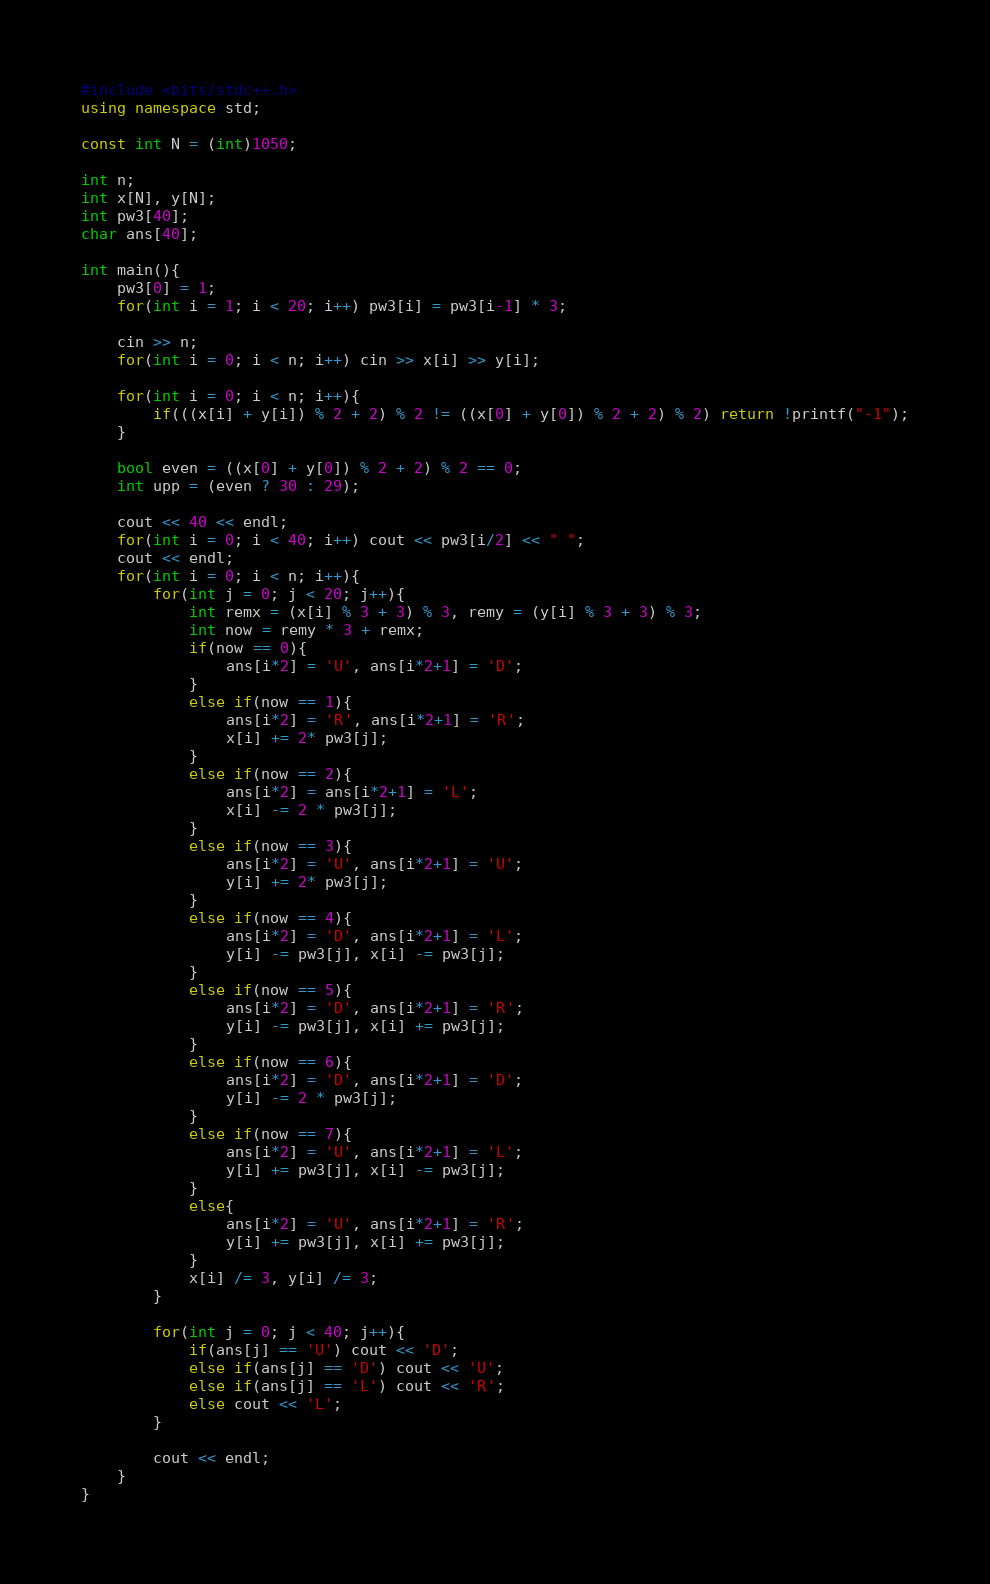<code> <loc_0><loc_0><loc_500><loc_500><_C++_>#include <bits/stdc++.h>
using namespace std;

const int N = (int)1050;

int n;
int x[N], y[N];
int pw3[40];
char ans[40];

int main(){
    pw3[0] = 1;
    for(int i = 1; i < 20; i++) pw3[i] = pw3[i-1] * 3;

    cin >> n;
    for(int i = 0; i < n; i++) cin >> x[i] >> y[i];

    for(int i = 0; i < n; i++){
        if(((x[i] + y[i]) % 2 + 2) % 2 != ((x[0] + y[0]) % 2 + 2) % 2) return !printf("-1");
    }

    bool even = ((x[0] + y[0]) % 2 + 2) % 2 == 0;
    int upp = (even ? 30 : 29);

    cout << 40 << endl;
    for(int i = 0; i < 40; i++) cout << pw3[i/2] << " ";
    cout << endl;
    for(int i = 0; i < n; i++){
        for(int j = 0; j < 20; j++){
            int remx = (x[i] % 3 + 3) % 3, remy = (y[i] % 3 + 3) % 3;
            int now = remy * 3 + remx;
            if(now == 0){
                ans[i*2] = 'U', ans[i*2+1] = 'D';
            }
            else if(now == 1){
                ans[i*2] = 'R', ans[i*2+1] = 'R';
                x[i] += 2* pw3[j];
            }
            else if(now == 2){
                ans[i*2] = ans[i*2+1] = 'L';
                x[i] -= 2 * pw3[j];
            }
            else if(now == 3){
                ans[i*2] = 'U', ans[i*2+1] = 'U';
                y[i] += 2* pw3[j];
            }
            else if(now == 4){
                ans[i*2] = 'D', ans[i*2+1] = 'L';
                y[i] -= pw3[j], x[i] -= pw3[j];
            }
            else if(now == 5){
                ans[i*2] = 'D', ans[i*2+1] = 'R';
                y[i] -= pw3[j], x[i] += pw3[j];
            }
            else if(now == 6){
                ans[i*2] = 'D', ans[i*2+1] = 'D';
                y[i] -= 2 * pw3[j];
            }
            else if(now == 7){
                ans[i*2] = 'U', ans[i*2+1] = 'L';
                y[i] += pw3[j], x[i] -= pw3[j];
            }
            else{
                ans[i*2] = 'U', ans[i*2+1] = 'R';
                y[i] += pw3[j], x[i] += pw3[j];
            }
            x[i] /= 3, y[i] /= 3;
        }

        for(int j = 0; j < 40; j++){
            if(ans[j] == 'U') cout << 'D';
            else if(ans[j] == 'D') cout << 'U';
            else if(ans[j] == 'L') cout << 'R';
            else cout << 'L';
        }

        cout << endl;
    }
}</code> 